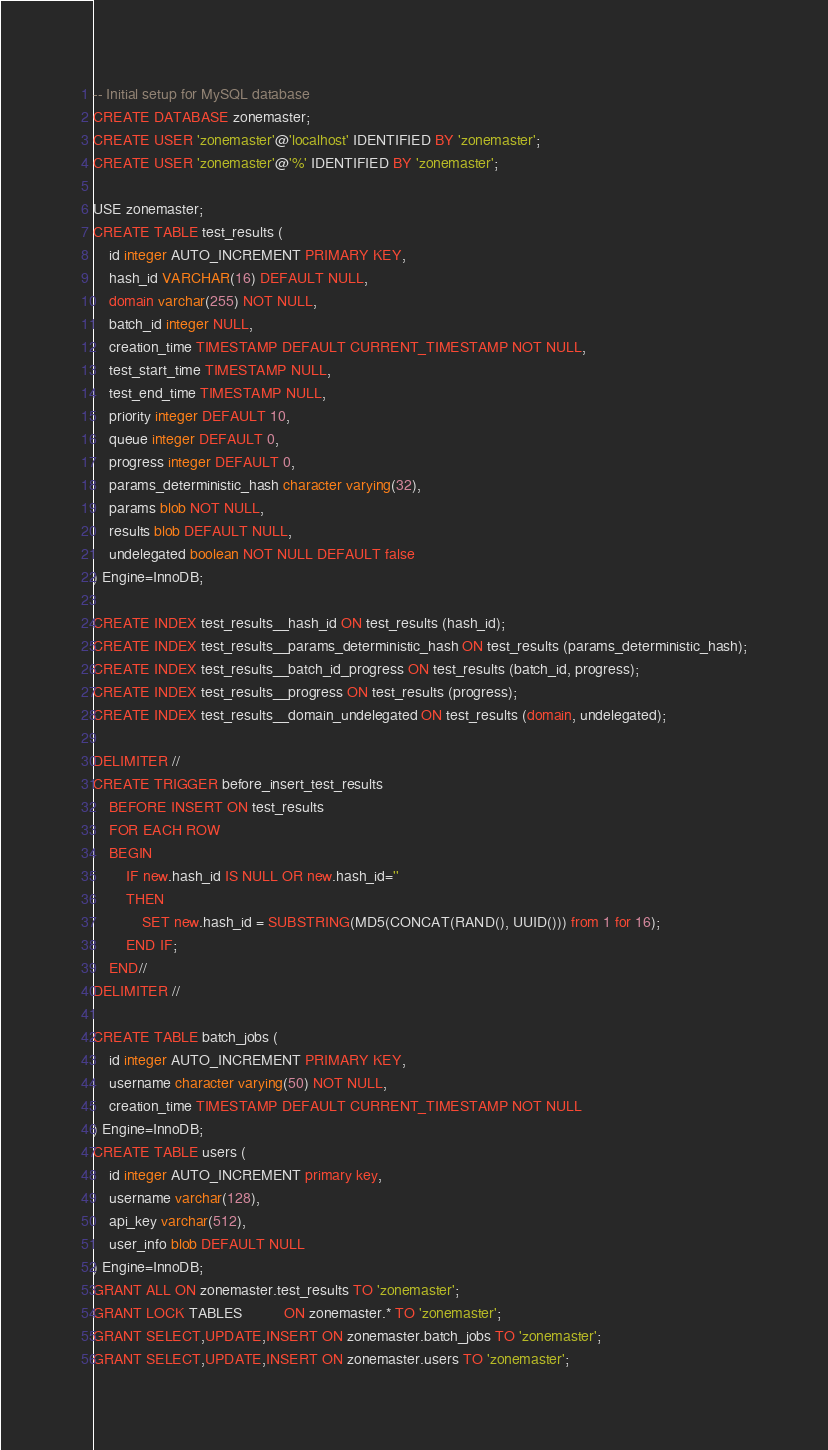Convert code to text. <code><loc_0><loc_0><loc_500><loc_500><_SQL_>-- Initial setup for MySQL database
CREATE DATABASE zonemaster;
CREATE USER 'zonemaster'@'localhost' IDENTIFIED BY 'zonemaster';
CREATE USER 'zonemaster'@'%' IDENTIFIED BY 'zonemaster';

USE zonemaster;
CREATE TABLE test_results (
    id integer AUTO_INCREMENT PRIMARY KEY,
    hash_id VARCHAR(16) DEFAULT NULL,
    domain varchar(255) NOT NULL,
	batch_id integer NULL,
	creation_time TIMESTAMP DEFAULT CURRENT_TIMESTAMP NOT NULL,
	test_start_time TIMESTAMP NULL,
	test_end_time TIMESTAMP NULL,
	priority integer DEFAULT 10,
	queue integer DEFAULT 0,
	progress integer DEFAULT 0,
	params_deterministic_hash character varying(32),
	params blob NOT NULL,
	results blob DEFAULT NULL,
    undelegated boolean NOT NULL DEFAULT false
) Engine=InnoDB;

CREATE INDEX test_results__hash_id ON test_results (hash_id);
CREATE INDEX test_results__params_deterministic_hash ON test_results (params_deterministic_hash);
CREATE INDEX test_results__batch_id_progress ON test_results (batch_id, progress);
CREATE INDEX test_results__progress ON test_results (progress);
CREATE INDEX test_results__domain_undelegated ON test_results (domain, undelegated);

DELIMITER //
CREATE TRIGGER before_insert_test_results
	BEFORE INSERT ON test_results
	FOR EACH ROW
	BEGIN
		IF new.hash_id IS NULL OR new.hash_id=''
		THEN
			SET new.hash_id = SUBSTRING(MD5(CONCAT(RAND(), UUID())) from 1 for 16);
		END IF;
	END//
DELIMITER //
			
CREATE TABLE batch_jobs (
    id integer AUTO_INCREMENT PRIMARY KEY,
    username character varying(50) NOT NULL,
    creation_time TIMESTAMP DEFAULT CURRENT_TIMESTAMP NOT NULL
) Engine=InnoDB;
CREATE TABLE users (
    id integer AUTO_INCREMENT primary key,
    username varchar(128),
    api_key varchar(512),
	user_info blob DEFAULT NULL
) Engine=InnoDB;
GRANT ALL ON zonemaster.test_results TO 'zonemaster';
GRANT LOCK TABLES          ON zonemaster.* TO 'zonemaster';
GRANT SELECT,UPDATE,INSERT ON zonemaster.batch_jobs TO 'zonemaster';
GRANT SELECT,UPDATE,INSERT ON zonemaster.users TO 'zonemaster';
</code> 